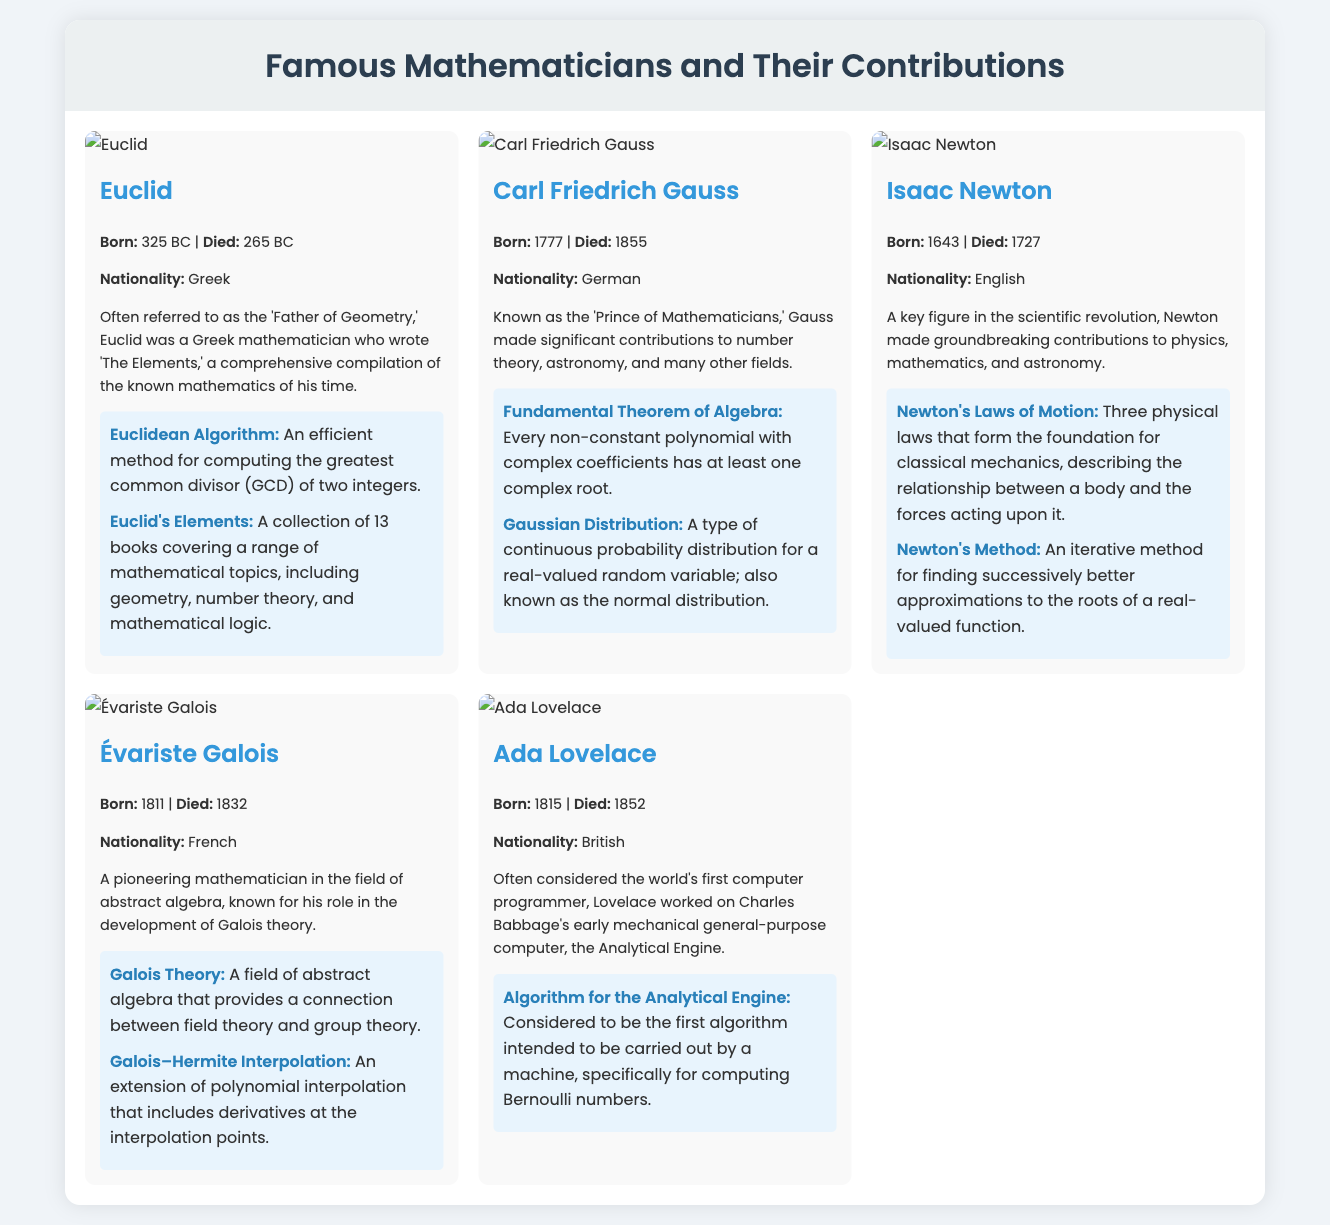What is Euclid often referred to as? The document states that Euclid is often referred to as the 'Father of Geometry.'
Answer: Father of Geometry What year was Ada Lovelace born? The document specifies that Ada Lovelace was born in 1815.
Answer: 1815 Which theorem is associated with Carl Friedrich Gauss? The document lists the Fundamental Theorem of Algebra as associated with Carl Friedrich Gauss.
Answer: Fundamental Theorem of Algebra What nationality was Évariste Galois? The document indicates that Évariste Galois was French.
Answer: French Which mathematician is known as the 'Prince of Mathematicians'? The document refers to Carl Friedrich Gauss as the 'Prince of Mathematicians.'
Answer: Carl Friedrich Gauss How many books are in Euclid's Elements? The document mentions that Euclid's Elements is a collection of 13 books.
Answer: 13 books What is Ada Lovelace known for? The document states that Ada Lovelace is considered the world's first computer programmer.
Answer: First computer programmer Which theorem relates to the relationship between field theory and group theory? The document specifies Galois Theory as the theorem that provides this connection.
Answer: Galois Theory What is the nationality of Isaac Newton? The document states that Isaac Newton was English.
Answer: English 